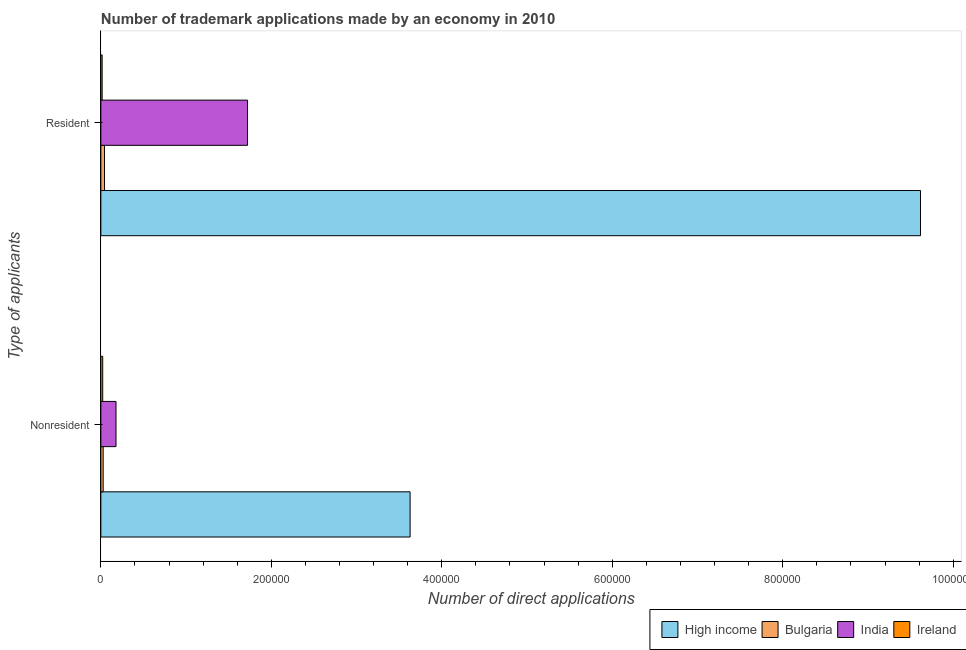How many different coloured bars are there?
Your answer should be compact. 4. How many groups of bars are there?
Make the answer very short. 2. Are the number of bars on each tick of the Y-axis equal?
Your answer should be very brief. Yes. What is the label of the 2nd group of bars from the top?
Provide a short and direct response. Nonresident. What is the number of trademark applications made by residents in Ireland?
Ensure brevity in your answer.  1539. Across all countries, what is the maximum number of trademark applications made by residents?
Your answer should be compact. 9.62e+05. Across all countries, what is the minimum number of trademark applications made by non residents?
Provide a succinct answer. 2198. In which country was the number of trademark applications made by residents maximum?
Provide a short and direct response. High income. In which country was the number of trademark applications made by residents minimum?
Keep it short and to the point. Ireland. What is the total number of trademark applications made by non residents in the graph?
Offer a very short reply. 3.86e+05. What is the difference between the number of trademark applications made by non residents in Bulgaria and that in High income?
Your answer should be very brief. -3.60e+05. What is the difference between the number of trademark applications made by non residents in India and the number of trademark applications made by residents in High income?
Provide a succinct answer. -9.44e+05. What is the average number of trademark applications made by non residents per country?
Your response must be concise. 9.64e+04. What is the difference between the number of trademark applications made by residents and number of trademark applications made by non residents in High income?
Ensure brevity in your answer.  5.99e+05. In how many countries, is the number of trademark applications made by non residents greater than 840000 ?
Provide a short and direct response. 0. What is the ratio of the number of trademark applications made by non residents in Bulgaria to that in India?
Your answer should be very brief. 0.15. What does the 2nd bar from the bottom in Resident represents?
Your response must be concise. Bulgaria. Are all the bars in the graph horizontal?
Offer a terse response. Yes. How many countries are there in the graph?
Provide a succinct answer. 4. Are the values on the major ticks of X-axis written in scientific E-notation?
Your answer should be very brief. No. Does the graph contain grids?
Make the answer very short. No. Where does the legend appear in the graph?
Give a very brief answer. Bottom right. How many legend labels are there?
Offer a very short reply. 4. What is the title of the graph?
Provide a short and direct response. Number of trademark applications made by an economy in 2010. What is the label or title of the X-axis?
Ensure brevity in your answer.  Number of direct applications. What is the label or title of the Y-axis?
Offer a terse response. Type of applicants. What is the Number of direct applications in High income in Nonresident?
Provide a succinct answer. 3.63e+05. What is the Number of direct applications of Bulgaria in Nonresident?
Keep it short and to the point. 2738. What is the Number of direct applications of India in Nonresident?
Your response must be concise. 1.78e+04. What is the Number of direct applications in Ireland in Nonresident?
Provide a succinct answer. 2198. What is the Number of direct applications of High income in Resident?
Offer a very short reply. 9.62e+05. What is the Number of direct applications of Bulgaria in Resident?
Give a very brief answer. 4308. What is the Number of direct applications of India in Resident?
Keep it short and to the point. 1.72e+05. What is the Number of direct applications of Ireland in Resident?
Keep it short and to the point. 1539. Across all Type of applicants, what is the maximum Number of direct applications in High income?
Provide a succinct answer. 9.62e+05. Across all Type of applicants, what is the maximum Number of direct applications in Bulgaria?
Give a very brief answer. 4308. Across all Type of applicants, what is the maximum Number of direct applications of India?
Ensure brevity in your answer.  1.72e+05. Across all Type of applicants, what is the maximum Number of direct applications in Ireland?
Give a very brief answer. 2198. Across all Type of applicants, what is the minimum Number of direct applications of High income?
Keep it short and to the point. 3.63e+05. Across all Type of applicants, what is the minimum Number of direct applications in Bulgaria?
Make the answer very short. 2738. Across all Type of applicants, what is the minimum Number of direct applications in India?
Provide a succinct answer. 1.78e+04. Across all Type of applicants, what is the minimum Number of direct applications of Ireland?
Offer a very short reply. 1539. What is the total Number of direct applications of High income in the graph?
Provide a succinct answer. 1.32e+06. What is the total Number of direct applications in Bulgaria in the graph?
Your answer should be very brief. 7046. What is the total Number of direct applications in India in the graph?
Provide a short and direct response. 1.90e+05. What is the total Number of direct applications of Ireland in the graph?
Give a very brief answer. 3737. What is the difference between the Number of direct applications in High income in Nonresident and that in Resident?
Provide a short and direct response. -5.99e+05. What is the difference between the Number of direct applications in Bulgaria in Nonresident and that in Resident?
Keep it short and to the point. -1570. What is the difference between the Number of direct applications in India in Nonresident and that in Resident?
Give a very brief answer. -1.54e+05. What is the difference between the Number of direct applications of Ireland in Nonresident and that in Resident?
Offer a terse response. 659. What is the difference between the Number of direct applications of High income in Nonresident and the Number of direct applications of Bulgaria in Resident?
Give a very brief answer. 3.59e+05. What is the difference between the Number of direct applications of High income in Nonresident and the Number of direct applications of India in Resident?
Give a very brief answer. 1.91e+05. What is the difference between the Number of direct applications of High income in Nonresident and the Number of direct applications of Ireland in Resident?
Your response must be concise. 3.61e+05. What is the difference between the Number of direct applications in Bulgaria in Nonresident and the Number of direct applications in India in Resident?
Your answer should be very brief. -1.69e+05. What is the difference between the Number of direct applications of Bulgaria in Nonresident and the Number of direct applications of Ireland in Resident?
Give a very brief answer. 1199. What is the difference between the Number of direct applications in India in Nonresident and the Number of direct applications in Ireland in Resident?
Provide a short and direct response. 1.63e+04. What is the average Number of direct applications of High income per Type of applicants?
Offer a very short reply. 6.62e+05. What is the average Number of direct applications in Bulgaria per Type of applicants?
Provide a succinct answer. 3523. What is the average Number of direct applications of India per Type of applicants?
Your response must be concise. 9.50e+04. What is the average Number of direct applications of Ireland per Type of applicants?
Your answer should be compact. 1868.5. What is the difference between the Number of direct applications of High income and Number of direct applications of Bulgaria in Nonresident?
Keep it short and to the point. 3.60e+05. What is the difference between the Number of direct applications in High income and Number of direct applications in India in Nonresident?
Keep it short and to the point. 3.45e+05. What is the difference between the Number of direct applications in High income and Number of direct applications in Ireland in Nonresident?
Ensure brevity in your answer.  3.61e+05. What is the difference between the Number of direct applications in Bulgaria and Number of direct applications in India in Nonresident?
Ensure brevity in your answer.  -1.51e+04. What is the difference between the Number of direct applications in Bulgaria and Number of direct applications in Ireland in Nonresident?
Your answer should be compact. 540. What is the difference between the Number of direct applications in India and Number of direct applications in Ireland in Nonresident?
Give a very brief answer. 1.56e+04. What is the difference between the Number of direct applications in High income and Number of direct applications in Bulgaria in Resident?
Offer a very short reply. 9.57e+05. What is the difference between the Number of direct applications in High income and Number of direct applications in India in Resident?
Ensure brevity in your answer.  7.90e+05. What is the difference between the Number of direct applications of High income and Number of direct applications of Ireland in Resident?
Keep it short and to the point. 9.60e+05. What is the difference between the Number of direct applications in Bulgaria and Number of direct applications in India in Resident?
Your answer should be compact. -1.68e+05. What is the difference between the Number of direct applications in Bulgaria and Number of direct applications in Ireland in Resident?
Offer a terse response. 2769. What is the difference between the Number of direct applications in India and Number of direct applications in Ireland in Resident?
Offer a very short reply. 1.71e+05. What is the ratio of the Number of direct applications in High income in Nonresident to that in Resident?
Your answer should be compact. 0.38. What is the ratio of the Number of direct applications of Bulgaria in Nonresident to that in Resident?
Ensure brevity in your answer.  0.64. What is the ratio of the Number of direct applications of India in Nonresident to that in Resident?
Offer a very short reply. 0.1. What is the ratio of the Number of direct applications of Ireland in Nonresident to that in Resident?
Your answer should be compact. 1.43. What is the difference between the highest and the second highest Number of direct applications in High income?
Give a very brief answer. 5.99e+05. What is the difference between the highest and the second highest Number of direct applications in Bulgaria?
Your answer should be compact. 1570. What is the difference between the highest and the second highest Number of direct applications in India?
Keep it short and to the point. 1.54e+05. What is the difference between the highest and the second highest Number of direct applications in Ireland?
Ensure brevity in your answer.  659. What is the difference between the highest and the lowest Number of direct applications of High income?
Provide a succinct answer. 5.99e+05. What is the difference between the highest and the lowest Number of direct applications in Bulgaria?
Provide a succinct answer. 1570. What is the difference between the highest and the lowest Number of direct applications of India?
Make the answer very short. 1.54e+05. What is the difference between the highest and the lowest Number of direct applications of Ireland?
Keep it short and to the point. 659. 